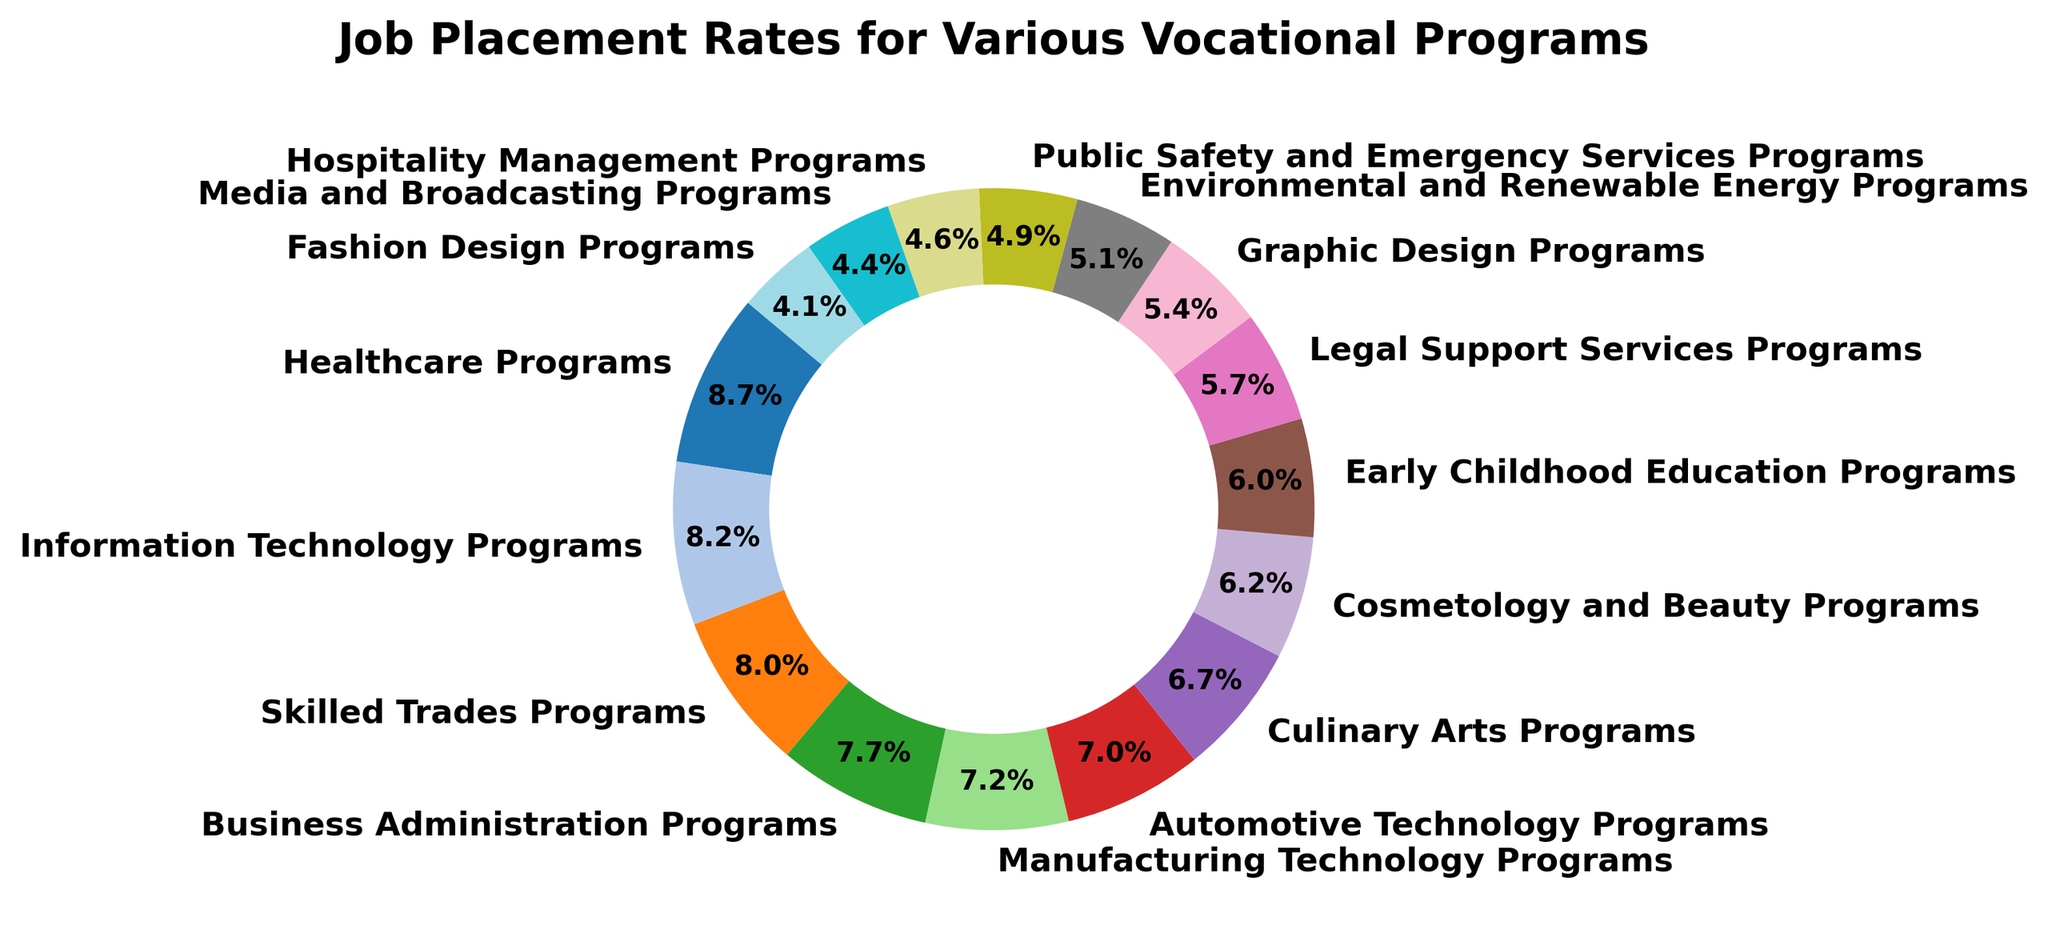Which vocational program has the highest job placement rate? The chart shows different vocational programs with varying job placement rates. The program with the largest section in the chart represents the highest rate. The largest section belongs to Healthcare Programs.
Answer: Healthcare Programs Which vocational program has the lowest job placement rate? The chart displays multiple vocational programs with corresponding job placement rates. The smallest section in the chart indicates the lowest rate. The smallest section belongs to Fashion Design Programs.
Answer: Fashion Design Programs How much higher is the job placement rate for Healthcare Programs compared to Fashion Design Programs? The Healthcare Programs section represents an 85% job placement rate, while Fashion Design Programs represent a 40% rate. Subtract the lower rate from the higher rate to find the difference: 85% - 40% = 45%.
Answer: 45% What is the average job placement rate of the top three programs? Identify the top three programs from the chart: Healthcare Programs(85%), Information Technology Programs(80%), and Skilled Trades Programs(78%). Calculate the average: (85 + 80 + 78) / 3 = 81%.
Answer: 81% Which vocational programs have a job placement rate above 70%? The chart shows the job placement rates of various vocational programs. Programs with a placement rate above 70% are Healthcare Programs, Information Technology Programs, Skilled Trades Programs, and Business Administration Programs.
Answer: Healthcare Programs, Information Technology Programs, Skilled Trades Programs, Business Administration Programs How much greater is the job placement rate for Information Technology Programs compared to Culinary Arts Programs? According to the chart, Information Technology Programs have a job placement rate of 80%, while Culinary Arts Programs have a 65% rate. Subtract the lower rate from the higher rate: 80% - 65% = 15%.
Answer: 15% Which program has a higher rate: Cosmetology and Beauty Programs or Graphic Design Programs? The chart shows job placement rates for various programs. Cosmetology and Beauty Programs have a 60% rate, while Graphic Design Programs have a 53% rate. Cosmetology and Beauty Programs have the higher rate.
Answer: Cosmetology and Beauty Programs What is the combined percentage of job placement rates for Environmental and Renewable Energy Programs and Public Safety and Emergency Services Programs? The job placement rate for Environmental and Renewable Energy Programs is 50% and for Public Safety and Emergency Services Programs is 48%. Add these rates together: 50% + 48% = 98%.
Answer: 98% Which vocational program with a job placement rate below 60% is closest to that threshold? Review the chart for programs below 60%. Early Childhood Education Programs have a 58% rate, which is closest to the 60% threshold.
Answer: Early Childhood Education Programs Which program has more than a 10% higher job placement rate compared to Hospitality Management Programs? Look at the chart to find the job placement rate for Hospitality Management Programs (45%). Programs with more than 55% rate meet this condition. Examples are Healthcare Programs, Information Technology Programs, Skilled Trades Programs, etc.
Answer: Healthcare Programs, Information Technology Programs, Skilled Trades Programs, Business Administration Programs, Manufacturing Technology Programs, Automotive Technology Programs, Culinary Arts Programs, Cosmetology and Beauty Programs, Early Childhood Education Programs, Legal Support Services Programs 